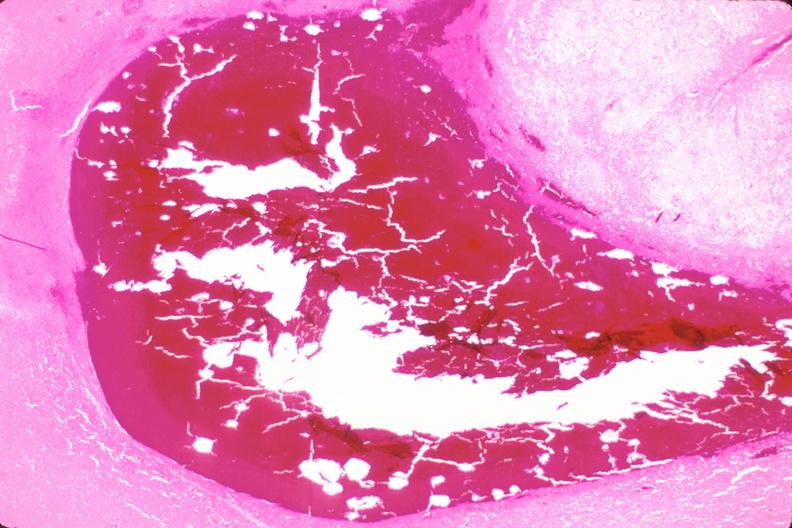why does this image show brain, subarachanoid hemorrhage and hematoma?
Answer the question using a single word or phrase. Due to ruptured aneurysm 